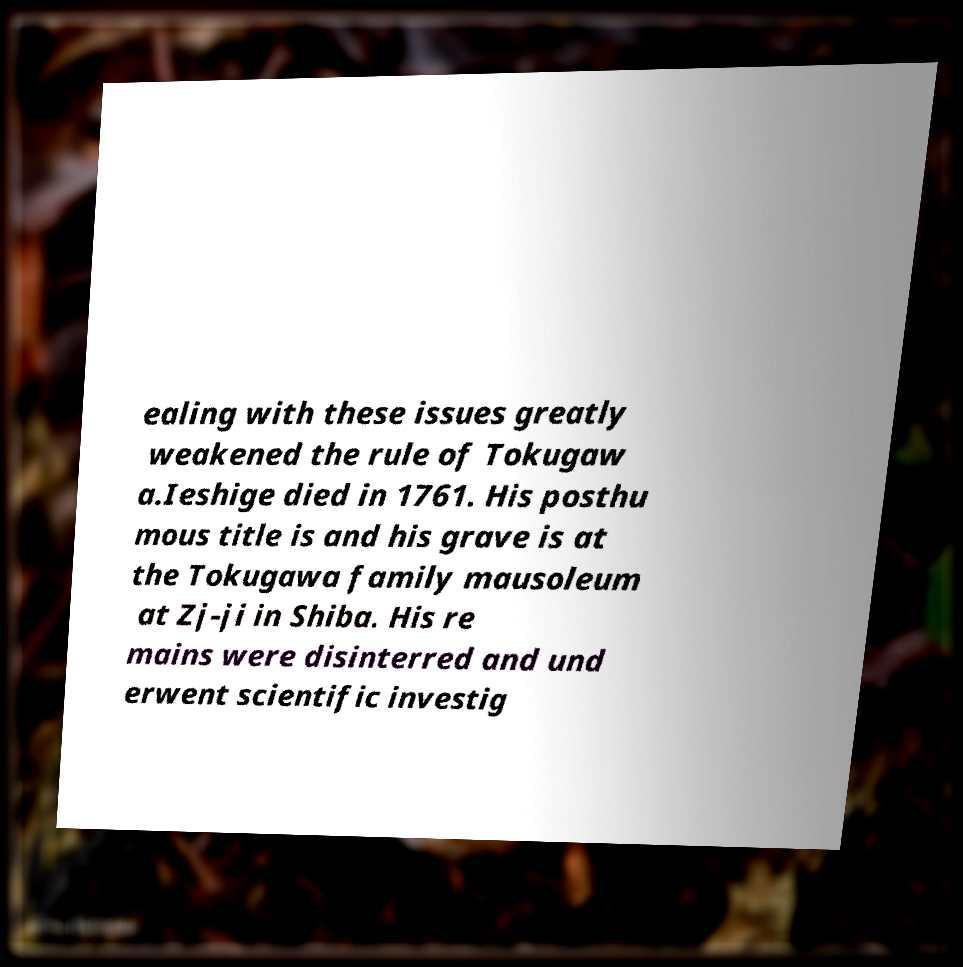I need the written content from this picture converted into text. Can you do that? ealing with these issues greatly weakened the rule of Tokugaw a.Ieshige died in 1761. His posthu mous title is and his grave is at the Tokugawa family mausoleum at Zj-ji in Shiba. His re mains were disinterred and und erwent scientific investig 